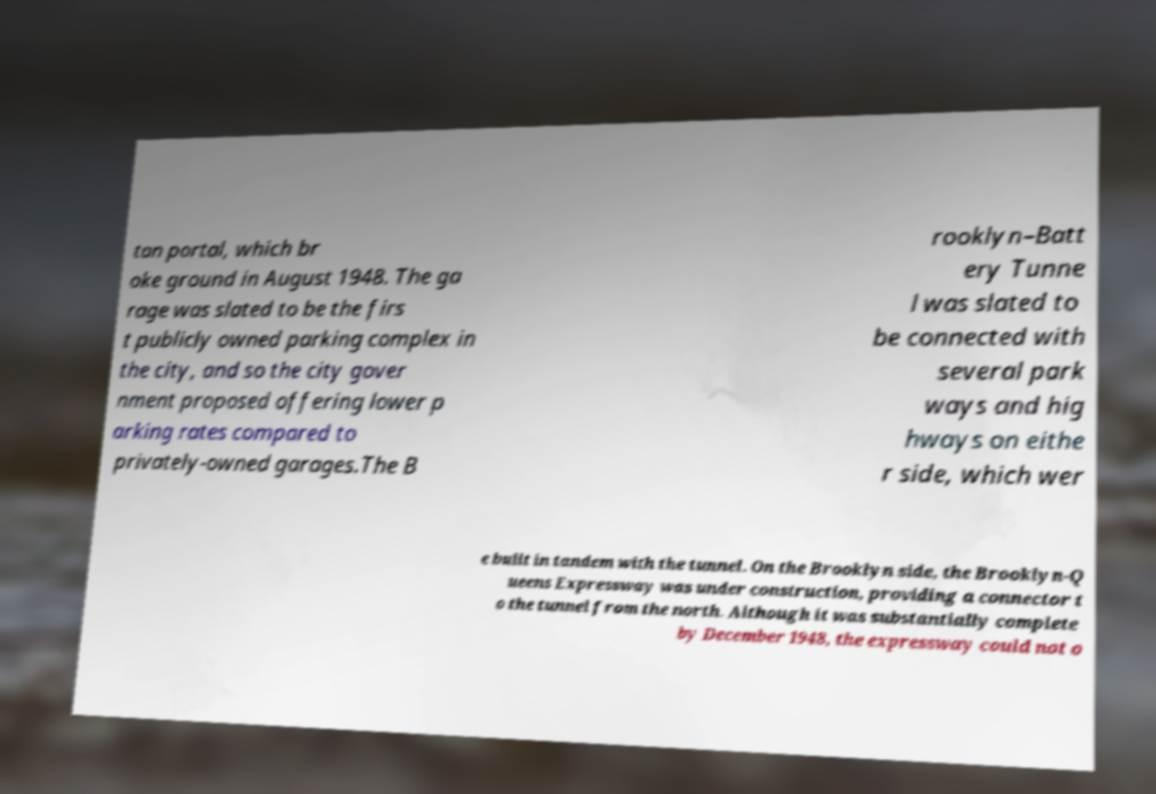I need the written content from this picture converted into text. Can you do that? tan portal, which br oke ground in August 1948. The ga rage was slated to be the firs t publicly owned parking complex in the city, and so the city gover nment proposed offering lower p arking rates compared to privately-owned garages.The B rooklyn–Batt ery Tunne l was slated to be connected with several park ways and hig hways on eithe r side, which wer e built in tandem with the tunnel. On the Brooklyn side, the Brooklyn-Q ueens Expressway was under construction, providing a connector t o the tunnel from the north. Although it was substantially complete by December 1948, the expressway could not o 